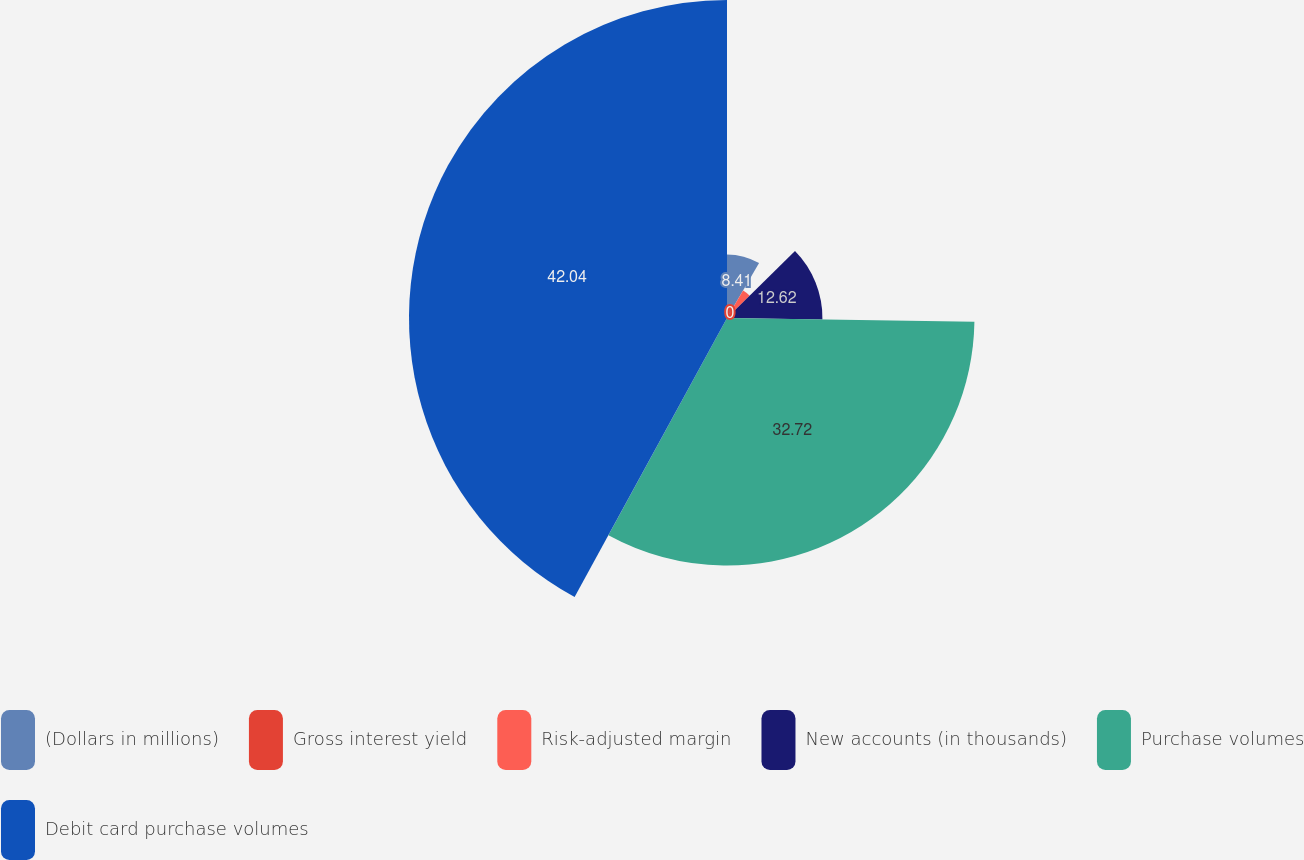Convert chart. <chart><loc_0><loc_0><loc_500><loc_500><pie_chart><fcel>(Dollars in millions)<fcel>Gross interest yield<fcel>Risk-adjusted margin<fcel>New accounts (in thousands)<fcel>Purchase volumes<fcel>Debit card purchase volumes<nl><fcel>8.41%<fcel>0.0%<fcel>4.21%<fcel>12.62%<fcel>32.72%<fcel>42.05%<nl></chart> 